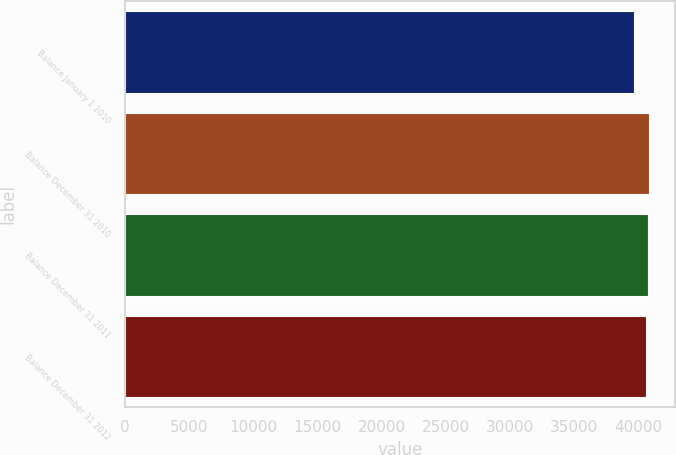<chart> <loc_0><loc_0><loc_500><loc_500><bar_chart><fcel>Balance January 1 2010<fcel>Balance December 31 2010<fcel>Balance December 31 2011<fcel>Balance December 31 2012<nl><fcel>39683<fcel>40849.6<fcel>40747.8<fcel>40646<nl></chart> 